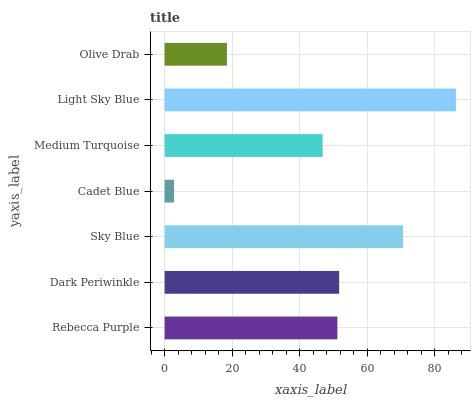Is Cadet Blue the minimum?
Answer yes or no. Yes. Is Light Sky Blue the maximum?
Answer yes or no. Yes. Is Dark Periwinkle the minimum?
Answer yes or no. No. Is Dark Periwinkle the maximum?
Answer yes or no. No. Is Dark Periwinkle greater than Rebecca Purple?
Answer yes or no. Yes. Is Rebecca Purple less than Dark Periwinkle?
Answer yes or no. Yes. Is Rebecca Purple greater than Dark Periwinkle?
Answer yes or no. No. Is Dark Periwinkle less than Rebecca Purple?
Answer yes or no. No. Is Rebecca Purple the high median?
Answer yes or no. Yes. Is Rebecca Purple the low median?
Answer yes or no. Yes. Is Sky Blue the high median?
Answer yes or no. No. Is Sky Blue the low median?
Answer yes or no. No. 